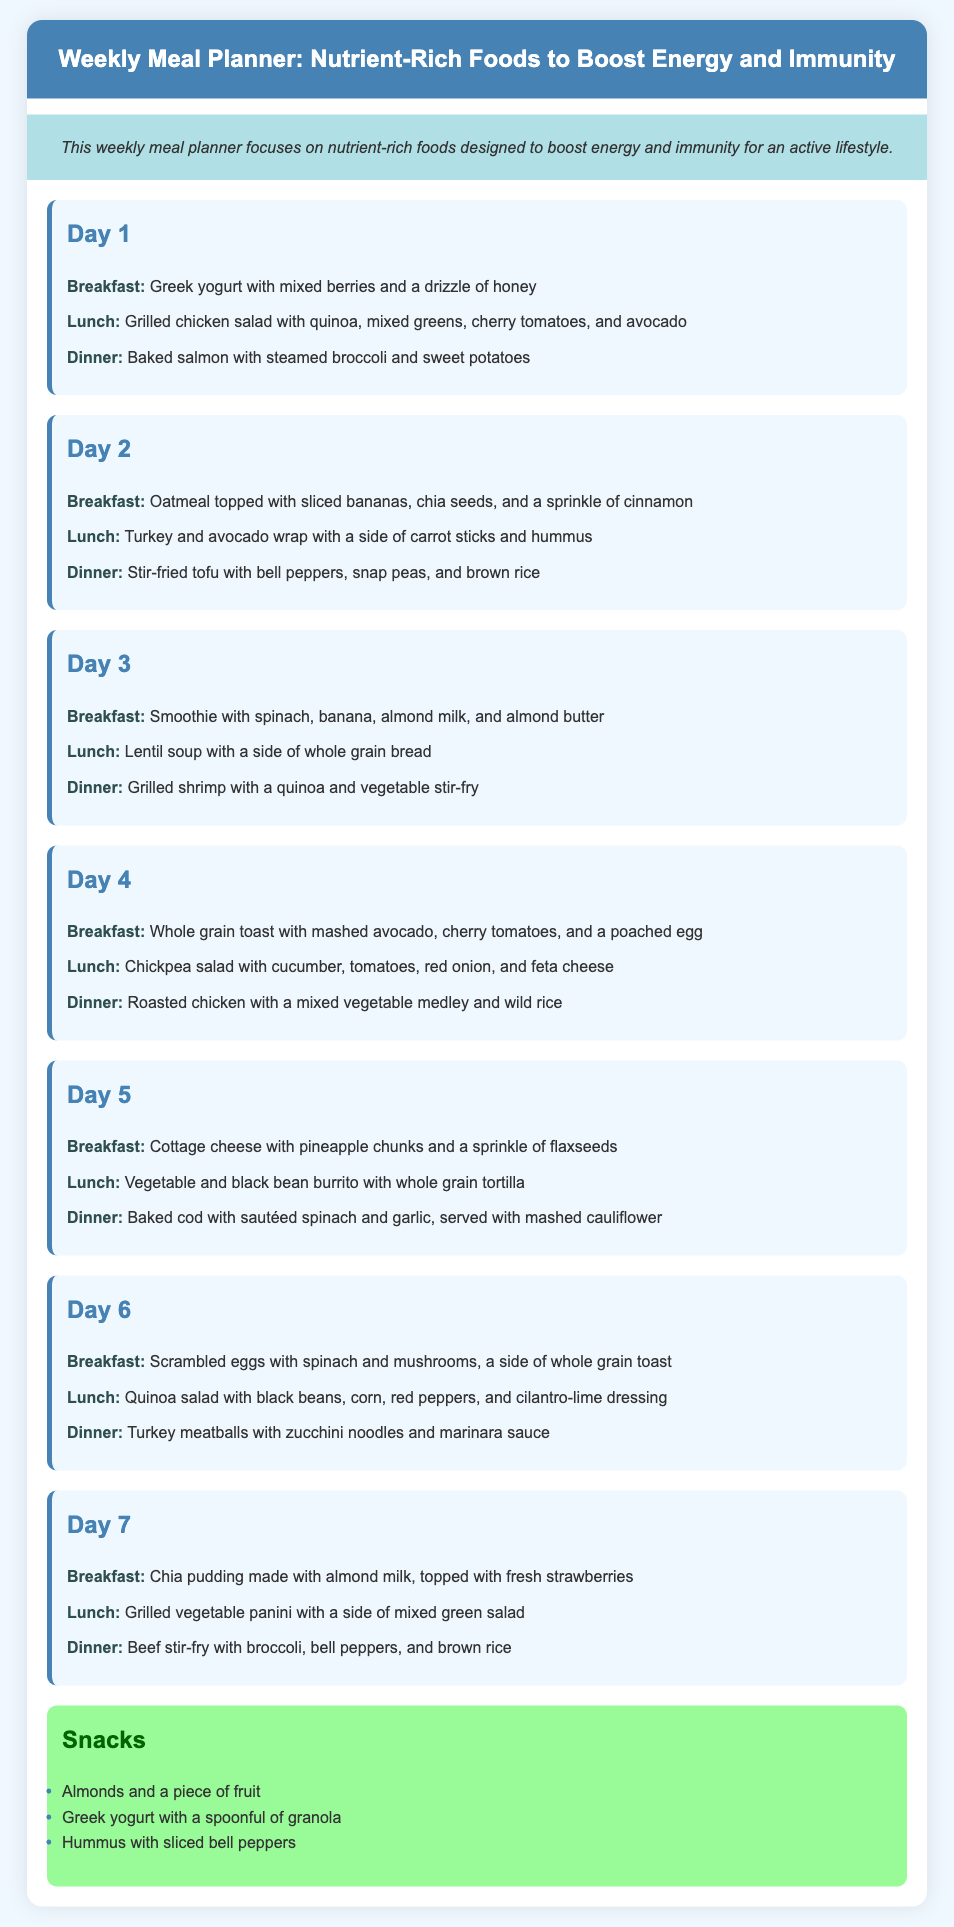What is the title of the document? The title of the document is prominently displayed at the top of the infographic.
Answer: Weekly Meal Planner: Nutrient-Rich Foods to Boost Energy and Immunity How many meals are listed for Day 1? Each day in the planner contains three meals: breakfast, lunch, and dinner.
Answer: 3 What is the dinner option for Day 3? The dinner option is specifically mentioned under Day 3 in the meal planner section.
Answer: Grilled shrimp with a quinoa and vegetable stir-fry Which snack includes hummus? The snacks section lists hummus as part of the snack options.
Answer: Hummus with sliced bell peppers Which day includes scrambled eggs? Scrambled eggs are detailed as part of the breakfast for a specific day in the planner.
Answer: Day 6 What type of salad is mentioned for Day 2 lunch? The type of salad is specifically stated under Day 2 lunch in the meal planner.
Answer: Turkey and avocado wrap What is used to make the chia pudding? The ingredients for the chia pudding are mentioned explicitly in the meal planner.
Answer: Almond milk 